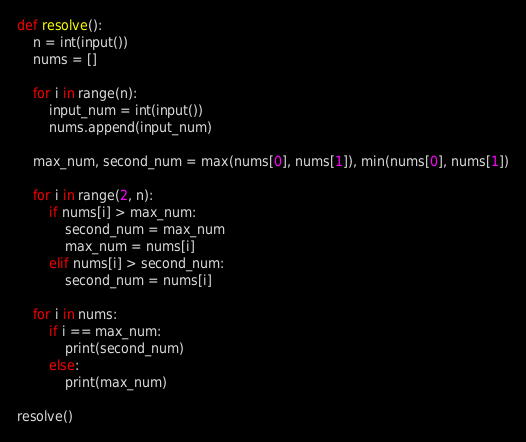<code> <loc_0><loc_0><loc_500><loc_500><_Python_>def resolve():
    n = int(input())
    nums = []

    for i in range(n):
        input_num = int(input())
        nums.append(input_num)

    max_num, second_num = max(nums[0], nums[1]), min(nums[0], nums[1])

    for i in range(2, n):
        if nums[i] > max_num:
            second_num = max_num
            max_num = nums[i]
        elif nums[i] > second_num:
            second_num = nums[i]

    for i in nums:
        if i == max_num:
            print(second_num)
        else:
            print(max_num)

resolve()</code> 